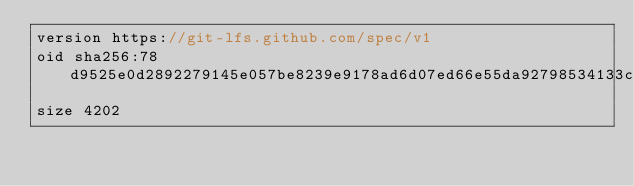Convert code to text. <code><loc_0><loc_0><loc_500><loc_500><_ObjectiveC_>version https://git-lfs.github.com/spec/v1
oid sha256:78d9525e0d2892279145e057be8239e9178ad6d07ed66e55da92798534133c64
size 4202
</code> 